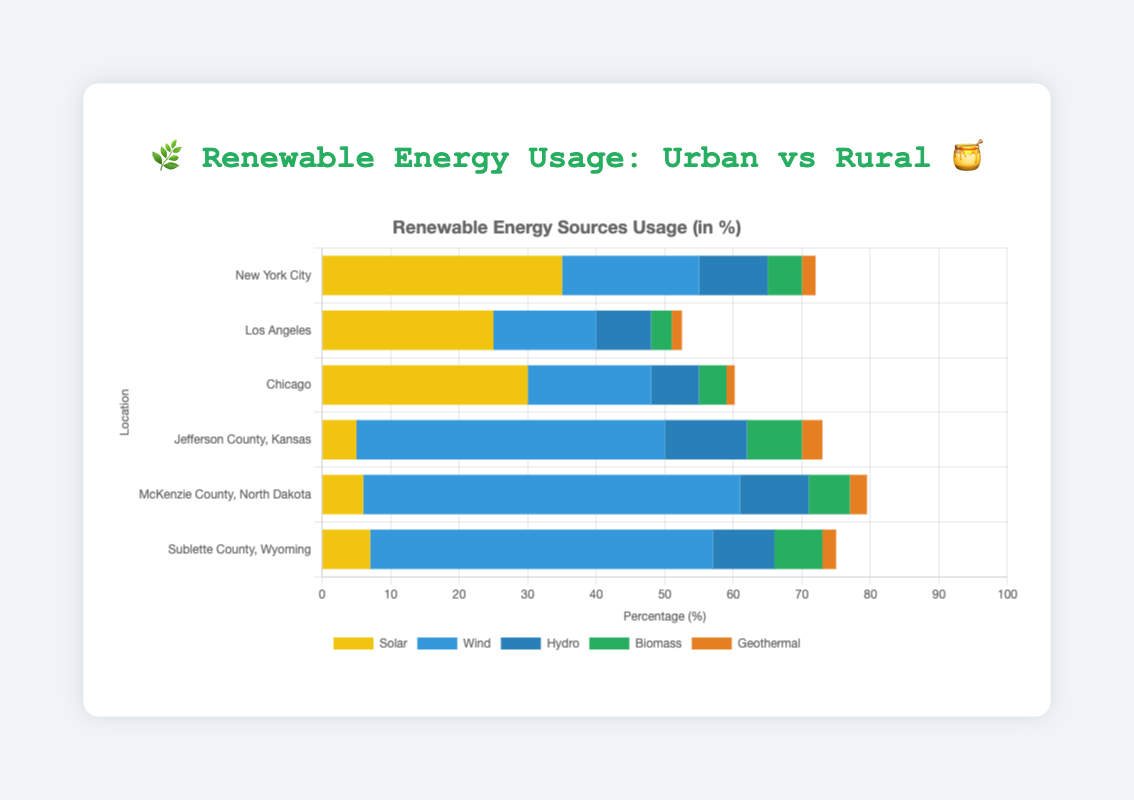What is the most used renewable energy source in New York City? By looking at the chart for New York City, the longest bar corresponds to the solar energy source.
Answer: Solar How much more wind energy does Jefferson County, Kansas use compared to Chicago? Jefferson County, Kansas has a wind energy usage value of 45, while Chicago has 18. Subtracting these gives 45 - 18 = 27.
Answer: 27 Which rural area has the highest usage of solar energy? McKenzie County, North Dakota has a solar energy value of 6, Jefferson County, Kansas has 5, and Sublette County, Wyoming has 7. Sublette County, Wyoming has the highest value.
Answer: Sublette County, Wyoming Compare the total renewable energy usage between Los Angeles and McKenzie County, North Dakota. Which one is higher? Los Angeles has a total renewable energy usage of 52.5, whereas McKenzie County, North Dakota has a total of 79.5. McKenzie County, North Dakota has the higher value.
Answer: McKenzie County, North Dakota What is the total usage of hydro energy in rural areas? Summing up hydro energy values in rural areas: Jefferson County, Kansas = 12, McKenzie County, North Dakota = 10, Sublette County, Wyoming = 9. So, 12 + 10 + 9 = 31.
Answer: 31 In which city is the difference between solar and wind energy usage the greatest? New York City: 35 (solar) - 20 (wind) = 15, Los Angeles: 25 (solar) - 15 (wind) = 10, Chicago: 30 (solar) - 18 (wind) = 12. The greatest difference is in New York City with 15.
Answer: New York City Which area has the lowest geothermal energy usage, and what is its value? Checking the values, Los Angeles has the lowest geothermal usage at 1.5.
Answer: Los Angeles, 1.5 Which rural area uses biomass the most, and how much is it? Jefferson County, Kansas uses biomass 8, McKenzie County, North Dakota uses 6, and Sublette County, Wyoming uses 7. Jefferson County, Kansas uses the most, which is 8.
Answer: Jefferson County, Kansas, 8 How does the total renewable energy usage in cities compare to rural areas? Summing total usage values in urban areas: New York City 72, Los Angeles 52.5, Chicago 60.2 which totals 184.7. In rural areas: Jefferson County, Kansas 73, McKenzie County, North Dakota 79.5, Sublette County, Wyoming 75 which totals 227.5. Rural areas have higher total usage.
Answer: Rural areas have higher total usage 